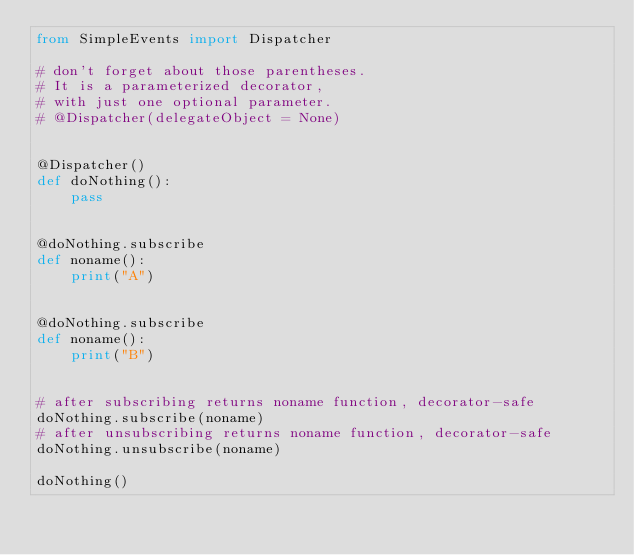<code> <loc_0><loc_0><loc_500><loc_500><_Python_>from SimpleEvents import Dispatcher

# don't forget about those parentheses.
# It is a parameterized decorator,
# with just one optional parameter.
# @Dispatcher(delegateObject = None)


@Dispatcher()
def doNothing():
    pass


@doNothing.subscribe
def noname():
    print("A")


@doNothing.subscribe
def noname():
    print("B")


# after subscribing returns noname function, decorator-safe
doNothing.subscribe(noname)
# after unsubscribing returns noname function, decorator-safe
doNothing.unsubscribe(noname)

doNothing()
</code> 